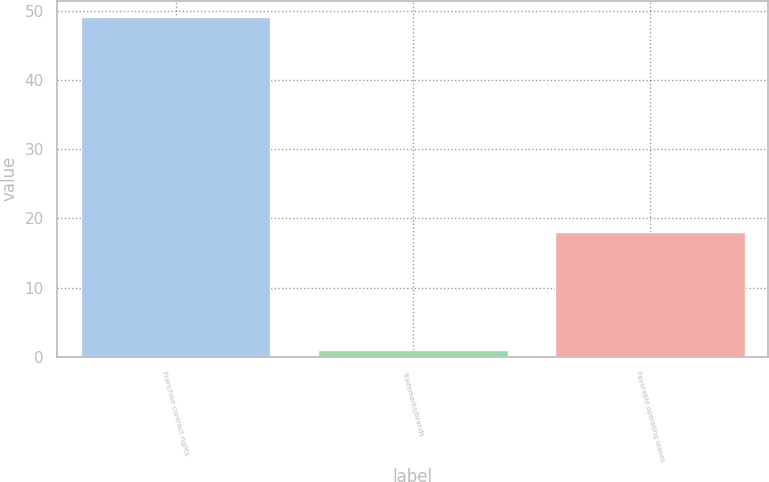Convert chart to OTSL. <chart><loc_0><loc_0><loc_500><loc_500><bar_chart><fcel>Franchise contract rights<fcel>Trademarks/brands<fcel>Favorable operating leases<nl><fcel>49<fcel>1<fcel>18<nl></chart> 